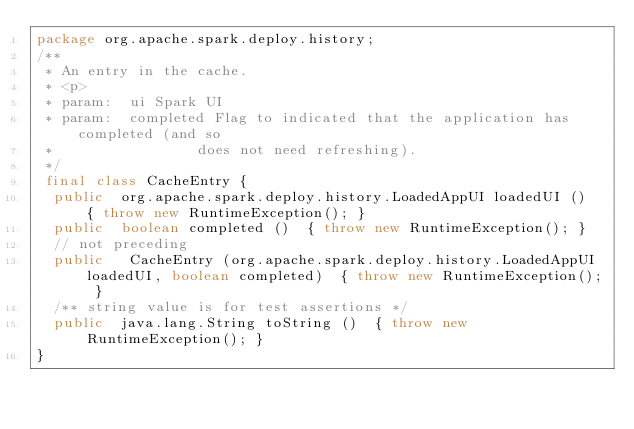Convert code to text. <code><loc_0><loc_0><loc_500><loc_500><_Java_>package org.apache.spark.deploy.history;
/**
 * An entry in the cache.
 * <p>
 * param:  ui Spark UI
 * param:  completed Flag to indicated that the application has completed (and so
 *                 does not need refreshing).
 */
 final class CacheEntry {
  public  org.apache.spark.deploy.history.LoadedAppUI loadedUI ()  { throw new RuntimeException(); }
  public  boolean completed ()  { throw new RuntimeException(); }
  // not preceding
  public   CacheEntry (org.apache.spark.deploy.history.LoadedAppUI loadedUI, boolean completed)  { throw new RuntimeException(); }
  /** string value is for test assertions */
  public  java.lang.String toString ()  { throw new RuntimeException(); }
}
</code> 